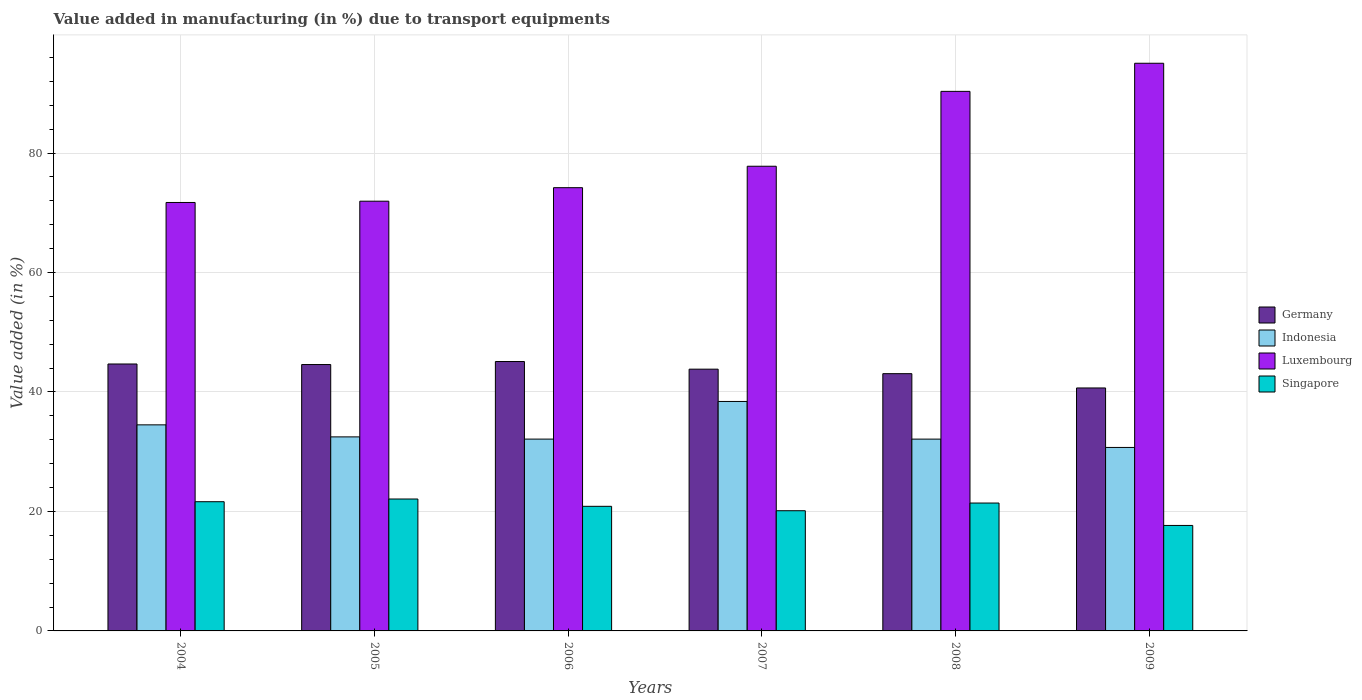How many different coloured bars are there?
Offer a terse response. 4. How many groups of bars are there?
Provide a short and direct response. 6. Are the number of bars on each tick of the X-axis equal?
Your response must be concise. Yes. What is the label of the 4th group of bars from the left?
Provide a short and direct response. 2007. In how many cases, is the number of bars for a given year not equal to the number of legend labels?
Keep it short and to the point. 0. What is the percentage of value added in manufacturing due to transport equipments in Singapore in 2004?
Your response must be concise. 21.63. Across all years, what is the maximum percentage of value added in manufacturing due to transport equipments in Germany?
Keep it short and to the point. 45.1. Across all years, what is the minimum percentage of value added in manufacturing due to transport equipments in Singapore?
Give a very brief answer. 17.66. What is the total percentage of value added in manufacturing due to transport equipments in Singapore in the graph?
Ensure brevity in your answer.  123.76. What is the difference between the percentage of value added in manufacturing due to transport equipments in Germany in 2006 and that in 2007?
Offer a terse response. 1.28. What is the difference between the percentage of value added in manufacturing due to transport equipments in Singapore in 2007 and the percentage of value added in manufacturing due to transport equipments in Luxembourg in 2004?
Your answer should be very brief. -51.6. What is the average percentage of value added in manufacturing due to transport equipments in Luxembourg per year?
Your answer should be very brief. 80.17. In the year 2004, what is the difference between the percentage of value added in manufacturing due to transport equipments in Germany and percentage of value added in manufacturing due to transport equipments in Luxembourg?
Your answer should be compact. -27.04. What is the ratio of the percentage of value added in manufacturing due to transport equipments in Luxembourg in 2006 to that in 2009?
Offer a terse response. 0.78. What is the difference between the highest and the second highest percentage of value added in manufacturing due to transport equipments in Luxembourg?
Your answer should be compact. 4.71. What is the difference between the highest and the lowest percentage of value added in manufacturing due to transport equipments in Germany?
Make the answer very short. 4.43. In how many years, is the percentage of value added in manufacturing due to transport equipments in Singapore greater than the average percentage of value added in manufacturing due to transport equipments in Singapore taken over all years?
Your response must be concise. 4. What does the 4th bar from the left in 2009 represents?
Keep it short and to the point. Singapore. What does the 3rd bar from the right in 2008 represents?
Your answer should be compact. Indonesia. Is it the case that in every year, the sum of the percentage of value added in manufacturing due to transport equipments in Singapore and percentage of value added in manufacturing due to transport equipments in Germany is greater than the percentage of value added in manufacturing due to transport equipments in Indonesia?
Make the answer very short. Yes. What is the difference between two consecutive major ticks on the Y-axis?
Your answer should be compact. 20. How many legend labels are there?
Provide a succinct answer. 4. What is the title of the graph?
Keep it short and to the point. Value added in manufacturing (in %) due to transport equipments. Does "Samoa" appear as one of the legend labels in the graph?
Keep it short and to the point. No. What is the label or title of the X-axis?
Your answer should be compact. Years. What is the label or title of the Y-axis?
Make the answer very short. Value added (in %). What is the Value added (in %) in Germany in 2004?
Provide a succinct answer. 44.69. What is the Value added (in %) of Indonesia in 2004?
Offer a very short reply. 34.5. What is the Value added (in %) in Luxembourg in 2004?
Ensure brevity in your answer.  71.73. What is the Value added (in %) of Singapore in 2004?
Make the answer very short. 21.63. What is the Value added (in %) of Germany in 2005?
Your answer should be very brief. 44.6. What is the Value added (in %) in Indonesia in 2005?
Make the answer very short. 32.48. What is the Value added (in %) in Luxembourg in 2005?
Provide a succinct answer. 71.94. What is the Value added (in %) of Singapore in 2005?
Your answer should be very brief. 22.08. What is the Value added (in %) in Germany in 2006?
Your answer should be very brief. 45.1. What is the Value added (in %) in Indonesia in 2006?
Give a very brief answer. 32.11. What is the Value added (in %) of Luxembourg in 2006?
Your response must be concise. 74.2. What is the Value added (in %) of Singapore in 2006?
Keep it short and to the point. 20.86. What is the Value added (in %) in Germany in 2007?
Keep it short and to the point. 43.82. What is the Value added (in %) of Indonesia in 2007?
Give a very brief answer. 38.41. What is the Value added (in %) of Luxembourg in 2007?
Ensure brevity in your answer.  77.79. What is the Value added (in %) of Singapore in 2007?
Offer a very short reply. 20.12. What is the Value added (in %) of Germany in 2008?
Your answer should be very brief. 43.07. What is the Value added (in %) in Indonesia in 2008?
Offer a very short reply. 32.11. What is the Value added (in %) in Luxembourg in 2008?
Provide a short and direct response. 90.32. What is the Value added (in %) in Singapore in 2008?
Your answer should be very brief. 21.41. What is the Value added (in %) in Germany in 2009?
Ensure brevity in your answer.  40.67. What is the Value added (in %) of Indonesia in 2009?
Ensure brevity in your answer.  30.72. What is the Value added (in %) in Luxembourg in 2009?
Ensure brevity in your answer.  95.03. What is the Value added (in %) in Singapore in 2009?
Ensure brevity in your answer.  17.66. Across all years, what is the maximum Value added (in %) in Germany?
Offer a very short reply. 45.1. Across all years, what is the maximum Value added (in %) in Indonesia?
Your response must be concise. 38.41. Across all years, what is the maximum Value added (in %) in Luxembourg?
Keep it short and to the point. 95.03. Across all years, what is the maximum Value added (in %) in Singapore?
Provide a short and direct response. 22.08. Across all years, what is the minimum Value added (in %) of Germany?
Offer a very short reply. 40.67. Across all years, what is the minimum Value added (in %) of Indonesia?
Make the answer very short. 30.72. Across all years, what is the minimum Value added (in %) of Luxembourg?
Provide a succinct answer. 71.73. Across all years, what is the minimum Value added (in %) of Singapore?
Keep it short and to the point. 17.66. What is the total Value added (in %) in Germany in the graph?
Give a very brief answer. 261.94. What is the total Value added (in %) in Indonesia in the graph?
Keep it short and to the point. 200.33. What is the total Value added (in %) of Luxembourg in the graph?
Provide a succinct answer. 481.01. What is the total Value added (in %) in Singapore in the graph?
Offer a very short reply. 123.76. What is the difference between the Value added (in %) in Germany in 2004 and that in 2005?
Your answer should be very brief. 0.09. What is the difference between the Value added (in %) in Indonesia in 2004 and that in 2005?
Provide a succinct answer. 2.02. What is the difference between the Value added (in %) in Luxembourg in 2004 and that in 2005?
Provide a short and direct response. -0.21. What is the difference between the Value added (in %) of Singapore in 2004 and that in 2005?
Offer a very short reply. -0.45. What is the difference between the Value added (in %) of Germany in 2004 and that in 2006?
Your response must be concise. -0.41. What is the difference between the Value added (in %) in Indonesia in 2004 and that in 2006?
Keep it short and to the point. 2.39. What is the difference between the Value added (in %) of Luxembourg in 2004 and that in 2006?
Provide a succinct answer. -2.48. What is the difference between the Value added (in %) in Singapore in 2004 and that in 2006?
Keep it short and to the point. 0.77. What is the difference between the Value added (in %) of Germany in 2004 and that in 2007?
Your answer should be compact. 0.87. What is the difference between the Value added (in %) of Indonesia in 2004 and that in 2007?
Your response must be concise. -3.92. What is the difference between the Value added (in %) in Luxembourg in 2004 and that in 2007?
Give a very brief answer. -6.06. What is the difference between the Value added (in %) in Singapore in 2004 and that in 2007?
Ensure brevity in your answer.  1.51. What is the difference between the Value added (in %) of Germany in 2004 and that in 2008?
Your answer should be very brief. 1.62. What is the difference between the Value added (in %) in Indonesia in 2004 and that in 2008?
Ensure brevity in your answer.  2.39. What is the difference between the Value added (in %) of Luxembourg in 2004 and that in 2008?
Keep it short and to the point. -18.6. What is the difference between the Value added (in %) in Singapore in 2004 and that in 2008?
Give a very brief answer. 0.22. What is the difference between the Value added (in %) in Germany in 2004 and that in 2009?
Give a very brief answer. 4.01. What is the difference between the Value added (in %) of Indonesia in 2004 and that in 2009?
Offer a terse response. 3.78. What is the difference between the Value added (in %) in Luxembourg in 2004 and that in 2009?
Keep it short and to the point. -23.31. What is the difference between the Value added (in %) of Singapore in 2004 and that in 2009?
Give a very brief answer. 3.98. What is the difference between the Value added (in %) of Germany in 2005 and that in 2006?
Offer a terse response. -0.5. What is the difference between the Value added (in %) of Indonesia in 2005 and that in 2006?
Offer a terse response. 0.37. What is the difference between the Value added (in %) of Luxembourg in 2005 and that in 2006?
Provide a succinct answer. -2.26. What is the difference between the Value added (in %) in Singapore in 2005 and that in 2006?
Give a very brief answer. 1.22. What is the difference between the Value added (in %) of Germany in 2005 and that in 2007?
Provide a short and direct response. 0.77. What is the difference between the Value added (in %) of Indonesia in 2005 and that in 2007?
Offer a very short reply. -5.93. What is the difference between the Value added (in %) of Luxembourg in 2005 and that in 2007?
Offer a very short reply. -5.85. What is the difference between the Value added (in %) in Singapore in 2005 and that in 2007?
Provide a short and direct response. 1.96. What is the difference between the Value added (in %) in Germany in 2005 and that in 2008?
Your response must be concise. 1.53. What is the difference between the Value added (in %) of Indonesia in 2005 and that in 2008?
Provide a short and direct response. 0.37. What is the difference between the Value added (in %) in Luxembourg in 2005 and that in 2008?
Your answer should be compact. -18.39. What is the difference between the Value added (in %) in Singapore in 2005 and that in 2008?
Your response must be concise. 0.68. What is the difference between the Value added (in %) in Germany in 2005 and that in 2009?
Your response must be concise. 3.92. What is the difference between the Value added (in %) in Indonesia in 2005 and that in 2009?
Your answer should be very brief. 1.77. What is the difference between the Value added (in %) in Luxembourg in 2005 and that in 2009?
Offer a very short reply. -23.09. What is the difference between the Value added (in %) of Singapore in 2005 and that in 2009?
Make the answer very short. 4.43. What is the difference between the Value added (in %) in Germany in 2006 and that in 2007?
Keep it short and to the point. 1.28. What is the difference between the Value added (in %) in Indonesia in 2006 and that in 2007?
Offer a very short reply. -6.3. What is the difference between the Value added (in %) in Luxembourg in 2006 and that in 2007?
Offer a very short reply. -3.59. What is the difference between the Value added (in %) in Singapore in 2006 and that in 2007?
Provide a succinct answer. 0.74. What is the difference between the Value added (in %) of Germany in 2006 and that in 2008?
Your answer should be compact. 2.03. What is the difference between the Value added (in %) of Indonesia in 2006 and that in 2008?
Provide a short and direct response. 0. What is the difference between the Value added (in %) in Luxembourg in 2006 and that in 2008?
Give a very brief answer. -16.12. What is the difference between the Value added (in %) of Singapore in 2006 and that in 2008?
Offer a very short reply. -0.55. What is the difference between the Value added (in %) of Germany in 2006 and that in 2009?
Ensure brevity in your answer.  4.43. What is the difference between the Value added (in %) of Indonesia in 2006 and that in 2009?
Give a very brief answer. 1.4. What is the difference between the Value added (in %) of Luxembourg in 2006 and that in 2009?
Ensure brevity in your answer.  -20.83. What is the difference between the Value added (in %) of Singapore in 2006 and that in 2009?
Ensure brevity in your answer.  3.2. What is the difference between the Value added (in %) of Germany in 2007 and that in 2008?
Your answer should be very brief. 0.75. What is the difference between the Value added (in %) in Indonesia in 2007 and that in 2008?
Make the answer very short. 6.3. What is the difference between the Value added (in %) of Luxembourg in 2007 and that in 2008?
Make the answer very short. -12.53. What is the difference between the Value added (in %) in Singapore in 2007 and that in 2008?
Your answer should be very brief. -1.29. What is the difference between the Value added (in %) of Germany in 2007 and that in 2009?
Offer a terse response. 3.15. What is the difference between the Value added (in %) of Indonesia in 2007 and that in 2009?
Offer a very short reply. 7.7. What is the difference between the Value added (in %) of Luxembourg in 2007 and that in 2009?
Give a very brief answer. -17.24. What is the difference between the Value added (in %) in Singapore in 2007 and that in 2009?
Your response must be concise. 2.47. What is the difference between the Value added (in %) of Germany in 2008 and that in 2009?
Make the answer very short. 2.39. What is the difference between the Value added (in %) of Indonesia in 2008 and that in 2009?
Offer a terse response. 1.39. What is the difference between the Value added (in %) in Luxembourg in 2008 and that in 2009?
Provide a succinct answer. -4.71. What is the difference between the Value added (in %) of Singapore in 2008 and that in 2009?
Your answer should be compact. 3.75. What is the difference between the Value added (in %) in Germany in 2004 and the Value added (in %) in Indonesia in 2005?
Your response must be concise. 12.2. What is the difference between the Value added (in %) in Germany in 2004 and the Value added (in %) in Luxembourg in 2005?
Give a very brief answer. -27.25. What is the difference between the Value added (in %) of Germany in 2004 and the Value added (in %) of Singapore in 2005?
Your answer should be compact. 22.6. What is the difference between the Value added (in %) of Indonesia in 2004 and the Value added (in %) of Luxembourg in 2005?
Ensure brevity in your answer.  -37.44. What is the difference between the Value added (in %) in Indonesia in 2004 and the Value added (in %) in Singapore in 2005?
Make the answer very short. 12.41. What is the difference between the Value added (in %) of Luxembourg in 2004 and the Value added (in %) of Singapore in 2005?
Keep it short and to the point. 49.64. What is the difference between the Value added (in %) of Germany in 2004 and the Value added (in %) of Indonesia in 2006?
Your response must be concise. 12.58. What is the difference between the Value added (in %) of Germany in 2004 and the Value added (in %) of Luxembourg in 2006?
Your answer should be compact. -29.51. What is the difference between the Value added (in %) in Germany in 2004 and the Value added (in %) in Singapore in 2006?
Keep it short and to the point. 23.83. What is the difference between the Value added (in %) in Indonesia in 2004 and the Value added (in %) in Luxembourg in 2006?
Offer a very short reply. -39.7. What is the difference between the Value added (in %) in Indonesia in 2004 and the Value added (in %) in Singapore in 2006?
Your answer should be very brief. 13.64. What is the difference between the Value added (in %) of Luxembourg in 2004 and the Value added (in %) of Singapore in 2006?
Offer a very short reply. 50.87. What is the difference between the Value added (in %) of Germany in 2004 and the Value added (in %) of Indonesia in 2007?
Your response must be concise. 6.27. What is the difference between the Value added (in %) of Germany in 2004 and the Value added (in %) of Luxembourg in 2007?
Offer a terse response. -33.1. What is the difference between the Value added (in %) of Germany in 2004 and the Value added (in %) of Singapore in 2007?
Your answer should be compact. 24.56. What is the difference between the Value added (in %) in Indonesia in 2004 and the Value added (in %) in Luxembourg in 2007?
Your response must be concise. -43.29. What is the difference between the Value added (in %) in Indonesia in 2004 and the Value added (in %) in Singapore in 2007?
Provide a succinct answer. 14.38. What is the difference between the Value added (in %) in Luxembourg in 2004 and the Value added (in %) in Singapore in 2007?
Provide a short and direct response. 51.6. What is the difference between the Value added (in %) in Germany in 2004 and the Value added (in %) in Indonesia in 2008?
Your response must be concise. 12.58. What is the difference between the Value added (in %) in Germany in 2004 and the Value added (in %) in Luxembourg in 2008?
Your answer should be compact. -45.64. What is the difference between the Value added (in %) in Germany in 2004 and the Value added (in %) in Singapore in 2008?
Keep it short and to the point. 23.28. What is the difference between the Value added (in %) in Indonesia in 2004 and the Value added (in %) in Luxembourg in 2008?
Your answer should be compact. -55.83. What is the difference between the Value added (in %) in Indonesia in 2004 and the Value added (in %) in Singapore in 2008?
Make the answer very short. 13.09. What is the difference between the Value added (in %) of Luxembourg in 2004 and the Value added (in %) of Singapore in 2008?
Ensure brevity in your answer.  50.32. What is the difference between the Value added (in %) in Germany in 2004 and the Value added (in %) in Indonesia in 2009?
Provide a short and direct response. 13.97. What is the difference between the Value added (in %) in Germany in 2004 and the Value added (in %) in Luxembourg in 2009?
Your response must be concise. -50.34. What is the difference between the Value added (in %) in Germany in 2004 and the Value added (in %) in Singapore in 2009?
Offer a very short reply. 27.03. What is the difference between the Value added (in %) in Indonesia in 2004 and the Value added (in %) in Luxembourg in 2009?
Provide a succinct answer. -60.53. What is the difference between the Value added (in %) in Indonesia in 2004 and the Value added (in %) in Singapore in 2009?
Make the answer very short. 16.84. What is the difference between the Value added (in %) in Luxembourg in 2004 and the Value added (in %) in Singapore in 2009?
Provide a short and direct response. 54.07. What is the difference between the Value added (in %) in Germany in 2005 and the Value added (in %) in Indonesia in 2006?
Provide a short and direct response. 12.48. What is the difference between the Value added (in %) in Germany in 2005 and the Value added (in %) in Luxembourg in 2006?
Give a very brief answer. -29.61. What is the difference between the Value added (in %) in Germany in 2005 and the Value added (in %) in Singapore in 2006?
Your answer should be compact. 23.73. What is the difference between the Value added (in %) in Indonesia in 2005 and the Value added (in %) in Luxembourg in 2006?
Your answer should be very brief. -41.72. What is the difference between the Value added (in %) in Indonesia in 2005 and the Value added (in %) in Singapore in 2006?
Ensure brevity in your answer.  11.62. What is the difference between the Value added (in %) of Luxembourg in 2005 and the Value added (in %) of Singapore in 2006?
Keep it short and to the point. 51.08. What is the difference between the Value added (in %) in Germany in 2005 and the Value added (in %) in Indonesia in 2007?
Give a very brief answer. 6.18. What is the difference between the Value added (in %) of Germany in 2005 and the Value added (in %) of Luxembourg in 2007?
Ensure brevity in your answer.  -33.19. What is the difference between the Value added (in %) of Germany in 2005 and the Value added (in %) of Singapore in 2007?
Offer a terse response. 24.47. What is the difference between the Value added (in %) in Indonesia in 2005 and the Value added (in %) in Luxembourg in 2007?
Give a very brief answer. -45.31. What is the difference between the Value added (in %) of Indonesia in 2005 and the Value added (in %) of Singapore in 2007?
Make the answer very short. 12.36. What is the difference between the Value added (in %) in Luxembourg in 2005 and the Value added (in %) in Singapore in 2007?
Your answer should be very brief. 51.82. What is the difference between the Value added (in %) of Germany in 2005 and the Value added (in %) of Indonesia in 2008?
Provide a short and direct response. 12.49. What is the difference between the Value added (in %) in Germany in 2005 and the Value added (in %) in Luxembourg in 2008?
Ensure brevity in your answer.  -45.73. What is the difference between the Value added (in %) of Germany in 2005 and the Value added (in %) of Singapore in 2008?
Your answer should be compact. 23.19. What is the difference between the Value added (in %) in Indonesia in 2005 and the Value added (in %) in Luxembourg in 2008?
Make the answer very short. -57.84. What is the difference between the Value added (in %) of Indonesia in 2005 and the Value added (in %) of Singapore in 2008?
Provide a short and direct response. 11.07. What is the difference between the Value added (in %) of Luxembourg in 2005 and the Value added (in %) of Singapore in 2008?
Your response must be concise. 50.53. What is the difference between the Value added (in %) in Germany in 2005 and the Value added (in %) in Indonesia in 2009?
Keep it short and to the point. 13.88. What is the difference between the Value added (in %) of Germany in 2005 and the Value added (in %) of Luxembourg in 2009?
Offer a very short reply. -50.44. What is the difference between the Value added (in %) of Germany in 2005 and the Value added (in %) of Singapore in 2009?
Keep it short and to the point. 26.94. What is the difference between the Value added (in %) in Indonesia in 2005 and the Value added (in %) in Luxembourg in 2009?
Make the answer very short. -62.55. What is the difference between the Value added (in %) in Indonesia in 2005 and the Value added (in %) in Singapore in 2009?
Keep it short and to the point. 14.83. What is the difference between the Value added (in %) in Luxembourg in 2005 and the Value added (in %) in Singapore in 2009?
Give a very brief answer. 54.28. What is the difference between the Value added (in %) in Germany in 2006 and the Value added (in %) in Indonesia in 2007?
Provide a short and direct response. 6.69. What is the difference between the Value added (in %) of Germany in 2006 and the Value added (in %) of Luxembourg in 2007?
Offer a terse response. -32.69. What is the difference between the Value added (in %) in Germany in 2006 and the Value added (in %) in Singapore in 2007?
Ensure brevity in your answer.  24.98. What is the difference between the Value added (in %) in Indonesia in 2006 and the Value added (in %) in Luxembourg in 2007?
Your answer should be very brief. -45.68. What is the difference between the Value added (in %) of Indonesia in 2006 and the Value added (in %) of Singapore in 2007?
Provide a short and direct response. 11.99. What is the difference between the Value added (in %) of Luxembourg in 2006 and the Value added (in %) of Singapore in 2007?
Your answer should be compact. 54.08. What is the difference between the Value added (in %) of Germany in 2006 and the Value added (in %) of Indonesia in 2008?
Provide a succinct answer. 12.99. What is the difference between the Value added (in %) of Germany in 2006 and the Value added (in %) of Luxembourg in 2008?
Your answer should be compact. -45.23. What is the difference between the Value added (in %) in Germany in 2006 and the Value added (in %) in Singapore in 2008?
Provide a short and direct response. 23.69. What is the difference between the Value added (in %) in Indonesia in 2006 and the Value added (in %) in Luxembourg in 2008?
Your answer should be very brief. -58.21. What is the difference between the Value added (in %) in Indonesia in 2006 and the Value added (in %) in Singapore in 2008?
Provide a succinct answer. 10.7. What is the difference between the Value added (in %) in Luxembourg in 2006 and the Value added (in %) in Singapore in 2008?
Give a very brief answer. 52.79. What is the difference between the Value added (in %) of Germany in 2006 and the Value added (in %) of Indonesia in 2009?
Your answer should be compact. 14.38. What is the difference between the Value added (in %) in Germany in 2006 and the Value added (in %) in Luxembourg in 2009?
Your answer should be compact. -49.93. What is the difference between the Value added (in %) of Germany in 2006 and the Value added (in %) of Singapore in 2009?
Offer a terse response. 27.44. What is the difference between the Value added (in %) of Indonesia in 2006 and the Value added (in %) of Luxembourg in 2009?
Keep it short and to the point. -62.92. What is the difference between the Value added (in %) of Indonesia in 2006 and the Value added (in %) of Singapore in 2009?
Provide a short and direct response. 14.45. What is the difference between the Value added (in %) of Luxembourg in 2006 and the Value added (in %) of Singapore in 2009?
Provide a short and direct response. 56.55. What is the difference between the Value added (in %) of Germany in 2007 and the Value added (in %) of Indonesia in 2008?
Your response must be concise. 11.71. What is the difference between the Value added (in %) of Germany in 2007 and the Value added (in %) of Luxembourg in 2008?
Your answer should be compact. -46.5. What is the difference between the Value added (in %) of Germany in 2007 and the Value added (in %) of Singapore in 2008?
Make the answer very short. 22.41. What is the difference between the Value added (in %) in Indonesia in 2007 and the Value added (in %) in Luxembourg in 2008?
Keep it short and to the point. -51.91. What is the difference between the Value added (in %) of Indonesia in 2007 and the Value added (in %) of Singapore in 2008?
Offer a terse response. 17.01. What is the difference between the Value added (in %) of Luxembourg in 2007 and the Value added (in %) of Singapore in 2008?
Give a very brief answer. 56.38. What is the difference between the Value added (in %) of Germany in 2007 and the Value added (in %) of Indonesia in 2009?
Make the answer very short. 13.11. What is the difference between the Value added (in %) of Germany in 2007 and the Value added (in %) of Luxembourg in 2009?
Make the answer very short. -51.21. What is the difference between the Value added (in %) in Germany in 2007 and the Value added (in %) in Singapore in 2009?
Your response must be concise. 26.16. What is the difference between the Value added (in %) of Indonesia in 2007 and the Value added (in %) of Luxembourg in 2009?
Keep it short and to the point. -56.62. What is the difference between the Value added (in %) in Indonesia in 2007 and the Value added (in %) in Singapore in 2009?
Give a very brief answer. 20.76. What is the difference between the Value added (in %) in Luxembourg in 2007 and the Value added (in %) in Singapore in 2009?
Ensure brevity in your answer.  60.13. What is the difference between the Value added (in %) in Germany in 2008 and the Value added (in %) in Indonesia in 2009?
Provide a short and direct response. 12.35. What is the difference between the Value added (in %) of Germany in 2008 and the Value added (in %) of Luxembourg in 2009?
Provide a succinct answer. -51.97. What is the difference between the Value added (in %) in Germany in 2008 and the Value added (in %) in Singapore in 2009?
Your answer should be compact. 25.41. What is the difference between the Value added (in %) in Indonesia in 2008 and the Value added (in %) in Luxembourg in 2009?
Ensure brevity in your answer.  -62.92. What is the difference between the Value added (in %) in Indonesia in 2008 and the Value added (in %) in Singapore in 2009?
Provide a short and direct response. 14.45. What is the difference between the Value added (in %) of Luxembourg in 2008 and the Value added (in %) of Singapore in 2009?
Ensure brevity in your answer.  72.67. What is the average Value added (in %) in Germany per year?
Provide a short and direct response. 43.66. What is the average Value added (in %) in Indonesia per year?
Provide a short and direct response. 33.39. What is the average Value added (in %) in Luxembourg per year?
Your answer should be compact. 80.17. What is the average Value added (in %) in Singapore per year?
Offer a very short reply. 20.63. In the year 2004, what is the difference between the Value added (in %) of Germany and Value added (in %) of Indonesia?
Give a very brief answer. 10.19. In the year 2004, what is the difference between the Value added (in %) in Germany and Value added (in %) in Luxembourg?
Give a very brief answer. -27.04. In the year 2004, what is the difference between the Value added (in %) of Germany and Value added (in %) of Singapore?
Provide a short and direct response. 23.06. In the year 2004, what is the difference between the Value added (in %) in Indonesia and Value added (in %) in Luxembourg?
Offer a terse response. -37.23. In the year 2004, what is the difference between the Value added (in %) of Indonesia and Value added (in %) of Singapore?
Your response must be concise. 12.87. In the year 2004, what is the difference between the Value added (in %) of Luxembourg and Value added (in %) of Singapore?
Your answer should be very brief. 50.09. In the year 2005, what is the difference between the Value added (in %) in Germany and Value added (in %) in Indonesia?
Provide a short and direct response. 12.11. In the year 2005, what is the difference between the Value added (in %) of Germany and Value added (in %) of Luxembourg?
Ensure brevity in your answer.  -27.34. In the year 2005, what is the difference between the Value added (in %) in Germany and Value added (in %) in Singapore?
Offer a terse response. 22.51. In the year 2005, what is the difference between the Value added (in %) in Indonesia and Value added (in %) in Luxembourg?
Provide a succinct answer. -39.46. In the year 2005, what is the difference between the Value added (in %) of Indonesia and Value added (in %) of Singapore?
Your answer should be very brief. 10.4. In the year 2005, what is the difference between the Value added (in %) in Luxembourg and Value added (in %) in Singapore?
Provide a succinct answer. 49.85. In the year 2006, what is the difference between the Value added (in %) of Germany and Value added (in %) of Indonesia?
Ensure brevity in your answer.  12.99. In the year 2006, what is the difference between the Value added (in %) in Germany and Value added (in %) in Luxembourg?
Give a very brief answer. -29.1. In the year 2006, what is the difference between the Value added (in %) in Germany and Value added (in %) in Singapore?
Ensure brevity in your answer.  24.24. In the year 2006, what is the difference between the Value added (in %) in Indonesia and Value added (in %) in Luxembourg?
Keep it short and to the point. -42.09. In the year 2006, what is the difference between the Value added (in %) of Indonesia and Value added (in %) of Singapore?
Ensure brevity in your answer.  11.25. In the year 2006, what is the difference between the Value added (in %) in Luxembourg and Value added (in %) in Singapore?
Your answer should be compact. 53.34. In the year 2007, what is the difference between the Value added (in %) in Germany and Value added (in %) in Indonesia?
Offer a very short reply. 5.41. In the year 2007, what is the difference between the Value added (in %) of Germany and Value added (in %) of Luxembourg?
Your answer should be very brief. -33.97. In the year 2007, what is the difference between the Value added (in %) in Germany and Value added (in %) in Singapore?
Give a very brief answer. 23.7. In the year 2007, what is the difference between the Value added (in %) of Indonesia and Value added (in %) of Luxembourg?
Ensure brevity in your answer.  -39.38. In the year 2007, what is the difference between the Value added (in %) in Indonesia and Value added (in %) in Singapore?
Offer a terse response. 18.29. In the year 2007, what is the difference between the Value added (in %) of Luxembourg and Value added (in %) of Singapore?
Keep it short and to the point. 57.67. In the year 2008, what is the difference between the Value added (in %) of Germany and Value added (in %) of Indonesia?
Your answer should be compact. 10.96. In the year 2008, what is the difference between the Value added (in %) of Germany and Value added (in %) of Luxembourg?
Your response must be concise. -47.26. In the year 2008, what is the difference between the Value added (in %) of Germany and Value added (in %) of Singapore?
Make the answer very short. 21.66. In the year 2008, what is the difference between the Value added (in %) of Indonesia and Value added (in %) of Luxembourg?
Give a very brief answer. -58.22. In the year 2008, what is the difference between the Value added (in %) of Indonesia and Value added (in %) of Singapore?
Give a very brief answer. 10.7. In the year 2008, what is the difference between the Value added (in %) of Luxembourg and Value added (in %) of Singapore?
Your answer should be compact. 68.92. In the year 2009, what is the difference between the Value added (in %) in Germany and Value added (in %) in Indonesia?
Provide a short and direct response. 9.96. In the year 2009, what is the difference between the Value added (in %) of Germany and Value added (in %) of Luxembourg?
Offer a terse response. -54.36. In the year 2009, what is the difference between the Value added (in %) of Germany and Value added (in %) of Singapore?
Provide a succinct answer. 23.02. In the year 2009, what is the difference between the Value added (in %) of Indonesia and Value added (in %) of Luxembourg?
Make the answer very short. -64.32. In the year 2009, what is the difference between the Value added (in %) of Indonesia and Value added (in %) of Singapore?
Keep it short and to the point. 13.06. In the year 2009, what is the difference between the Value added (in %) in Luxembourg and Value added (in %) in Singapore?
Offer a terse response. 77.37. What is the ratio of the Value added (in %) of Germany in 2004 to that in 2005?
Offer a terse response. 1. What is the ratio of the Value added (in %) in Indonesia in 2004 to that in 2005?
Your answer should be very brief. 1.06. What is the ratio of the Value added (in %) of Luxembourg in 2004 to that in 2005?
Offer a terse response. 1. What is the ratio of the Value added (in %) of Singapore in 2004 to that in 2005?
Offer a very short reply. 0.98. What is the ratio of the Value added (in %) of Germany in 2004 to that in 2006?
Your answer should be very brief. 0.99. What is the ratio of the Value added (in %) in Indonesia in 2004 to that in 2006?
Provide a short and direct response. 1.07. What is the ratio of the Value added (in %) of Luxembourg in 2004 to that in 2006?
Make the answer very short. 0.97. What is the ratio of the Value added (in %) in Germany in 2004 to that in 2007?
Offer a very short reply. 1.02. What is the ratio of the Value added (in %) of Indonesia in 2004 to that in 2007?
Your response must be concise. 0.9. What is the ratio of the Value added (in %) in Luxembourg in 2004 to that in 2007?
Give a very brief answer. 0.92. What is the ratio of the Value added (in %) in Singapore in 2004 to that in 2007?
Offer a terse response. 1.07. What is the ratio of the Value added (in %) in Germany in 2004 to that in 2008?
Offer a very short reply. 1.04. What is the ratio of the Value added (in %) of Indonesia in 2004 to that in 2008?
Give a very brief answer. 1.07. What is the ratio of the Value added (in %) in Luxembourg in 2004 to that in 2008?
Ensure brevity in your answer.  0.79. What is the ratio of the Value added (in %) of Singapore in 2004 to that in 2008?
Ensure brevity in your answer.  1.01. What is the ratio of the Value added (in %) in Germany in 2004 to that in 2009?
Keep it short and to the point. 1.1. What is the ratio of the Value added (in %) of Indonesia in 2004 to that in 2009?
Your answer should be very brief. 1.12. What is the ratio of the Value added (in %) in Luxembourg in 2004 to that in 2009?
Give a very brief answer. 0.75. What is the ratio of the Value added (in %) of Singapore in 2004 to that in 2009?
Your answer should be compact. 1.23. What is the ratio of the Value added (in %) in Germany in 2005 to that in 2006?
Offer a very short reply. 0.99. What is the ratio of the Value added (in %) in Indonesia in 2005 to that in 2006?
Provide a short and direct response. 1.01. What is the ratio of the Value added (in %) in Luxembourg in 2005 to that in 2006?
Provide a short and direct response. 0.97. What is the ratio of the Value added (in %) in Singapore in 2005 to that in 2006?
Your answer should be very brief. 1.06. What is the ratio of the Value added (in %) in Germany in 2005 to that in 2007?
Offer a very short reply. 1.02. What is the ratio of the Value added (in %) in Indonesia in 2005 to that in 2007?
Your response must be concise. 0.85. What is the ratio of the Value added (in %) of Luxembourg in 2005 to that in 2007?
Ensure brevity in your answer.  0.92. What is the ratio of the Value added (in %) in Singapore in 2005 to that in 2007?
Provide a succinct answer. 1.1. What is the ratio of the Value added (in %) of Germany in 2005 to that in 2008?
Your answer should be very brief. 1.04. What is the ratio of the Value added (in %) in Indonesia in 2005 to that in 2008?
Make the answer very short. 1.01. What is the ratio of the Value added (in %) of Luxembourg in 2005 to that in 2008?
Keep it short and to the point. 0.8. What is the ratio of the Value added (in %) of Singapore in 2005 to that in 2008?
Make the answer very short. 1.03. What is the ratio of the Value added (in %) in Germany in 2005 to that in 2009?
Ensure brevity in your answer.  1.1. What is the ratio of the Value added (in %) of Indonesia in 2005 to that in 2009?
Your response must be concise. 1.06. What is the ratio of the Value added (in %) in Luxembourg in 2005 to that in 2009?
Provide a short and direct response. 0.76. What is the ratio of the Value added (in %) of Singapore in 2005 to that in 2009?
Offer a very short reply. 1.25. What is the ratio of the Value added (in %) of Germany in 2006 to that in 2007?
Provide a short and direct response. 1.03. What is the ratio of the Value added (in %) in Indonesia in 2006 to that in 2007?
Your answer should be very brief. 0.84. What is the ratio of the Value added (in %) in Luxembourg in 2006 to that in 2007?
Provide a short and direct response. 0.95. What is the ratio of the Value added (in %) of Singapore in 2006 to that in 2007?
Your answer should be compact. 1.04. What is the ratio of the Value added (in %) of Germany in 2006 to that in 2008?
Ensure brevity in your answer.  1.05. What is the ratio of the Value added (in %) of Luxembourg in 2006 to that in 2008?
Your answer should be very brief. 0.82. What is the ratio of the Value added (in %) of Singapore in 2006 to that in 2008?
Your answer should be compact. 0.97. What is the ratio of the Value added (in %) in Germany in 2006 to that in 2009?
Your answer should be compact. 1.11. What is the ratio of the Value added (in %) in Indonesia in 2006 to that in 2009?
Provide a short and direct response. 1.05. What is the ratio of the Value added (in %) of Luxembourg in 2006 to that in 2009?
Provide a short and direct response. 0.78. What is the ratio of the Value added (in %) in Singapore in 2006 to that in 2009?
Your answer should be compact. 1.18. What is the ratio of the Value added (in %) in Germany in 2007 to that in 2008?
Offer a terse response. 1.02. What is the ratio of the Value added (in %) in Indonesia in 2007 to that in 2008?
Make the answer very short. 1.2. What is the ratio of the Value added (in %) of Luxembourg in 2007 to that in 2008?
Your response must be concise. 0.86. What is the ratio of the Value added (in %) of Germany in 2007 to that in 2009?
Ensure brevity in your answer.  1.08. What is the ratio of the Value added (in %) in Indonesia in 2007 to that in 2009?
Ensure brevity in your answer.  1.25. What is the ratio of the Value added (in %) of Luxembourg in 2007 to that in 2009?
Offer a very short reply. 0.82. What is the ratio of the Value added (in %) in Singapore in 2007 to that in 2009?
Your response must be concise. 1.14. What is the ratio of the Value added (in %) in Germany in 2008 to that in 2009?
Keep it short and to the point. 1.06. What is the ratio of the Value added (in %) in Indonesia in 2008 to that in 2009?
Give a very brief answer. 1.05. What is the ratio of the Value added (in %) of Luxembourg in 2008 to that in 2009?
Provide a succinct answer. 0.95. What is the ratio of the Value added (in %) of Singapore in 2008 to that in 2009?
Your answer should be very brief. 1.21. What is the difference between the highest and the second highest Value added (in %) of Germany?
Provide a short and direct response. 0.41. What is the difference between the highest and the second highest Value added (in %) of Indonesia?
Your response must be concise. 3.92. What is the difference between the highest and the second highest Value added (in %) of Luxembourg?
Give a very brief answer. 4.71. What is the difference between the highest and the second highest Value added (in %) of Singapore?
Offer a very short reply. 0.45. What is the difference between the highest and the lowest Value added (in %) in Germany?
Give a very brief answer. 4.43. What is the difference between the highest and the lowest Value added (in %) in Indonesia?
Provide a short and direct response. 7.7. What is the difference between the highest and the lowest Value added (in %) in Luxembourg?
Your answer should be very brief. 23.31. What is the difference between the highest and the lowest Value added (in %) of Singapore?
Your answer should be compact. 4.43. 